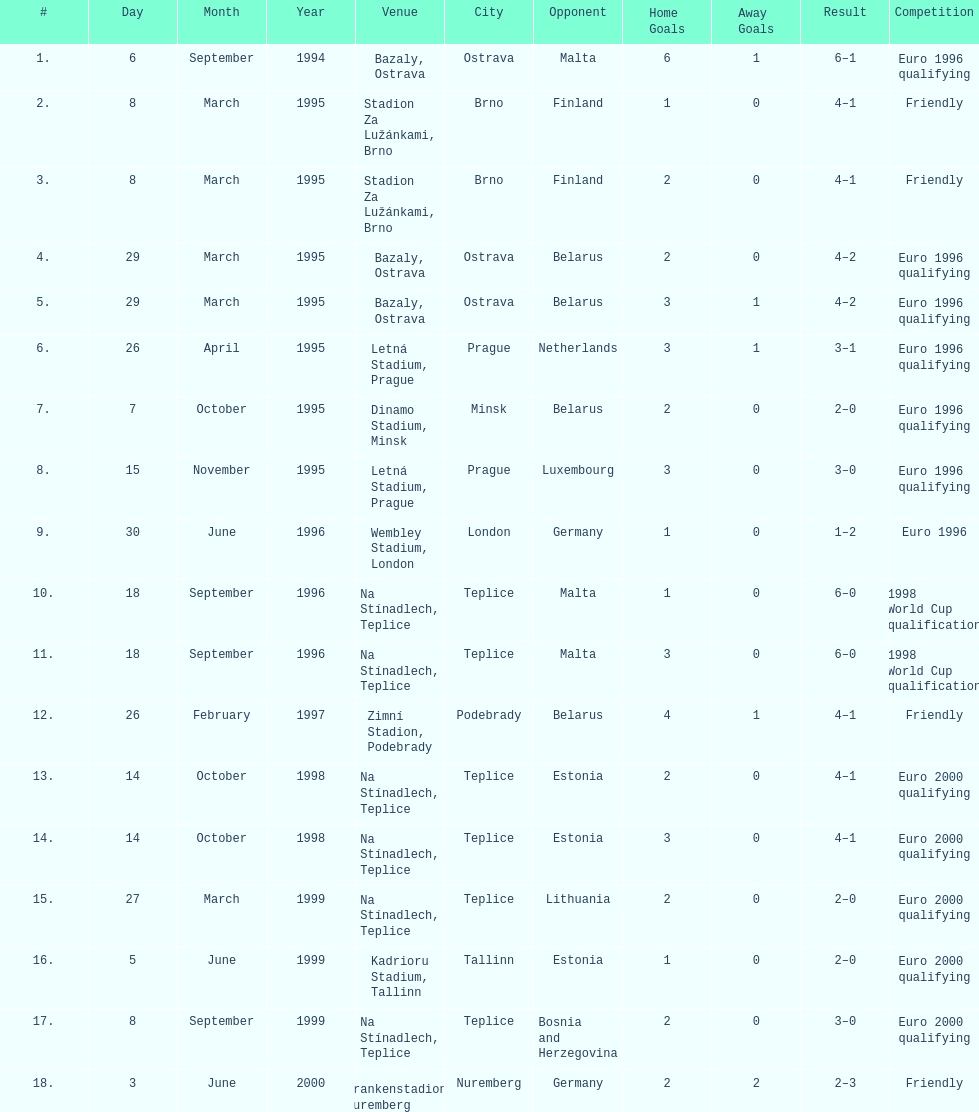Which team did czech republic score the most goals against? Malta. 